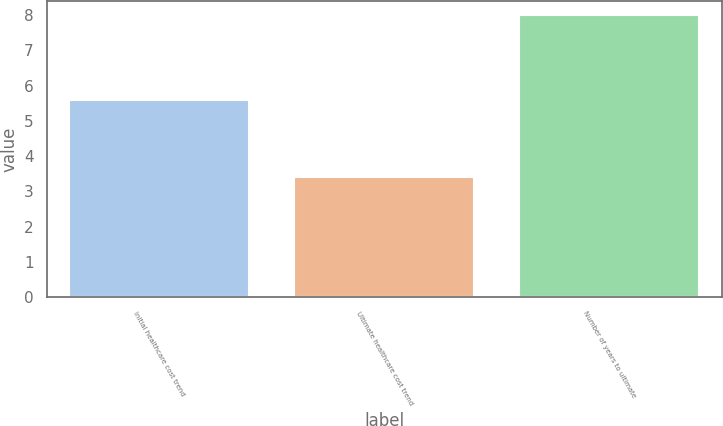Convert chart to OTSL. <chart><loc_0><loc_0><loc_500><loc_500><bar_chart><fcel>Initial healthcare cost trend<fcel>Ultimate healthcare cost trend<fcel>Number of years to ultimate<nl><fcel>5.6<fcel>3.4<fcel>8<nl></chart> 